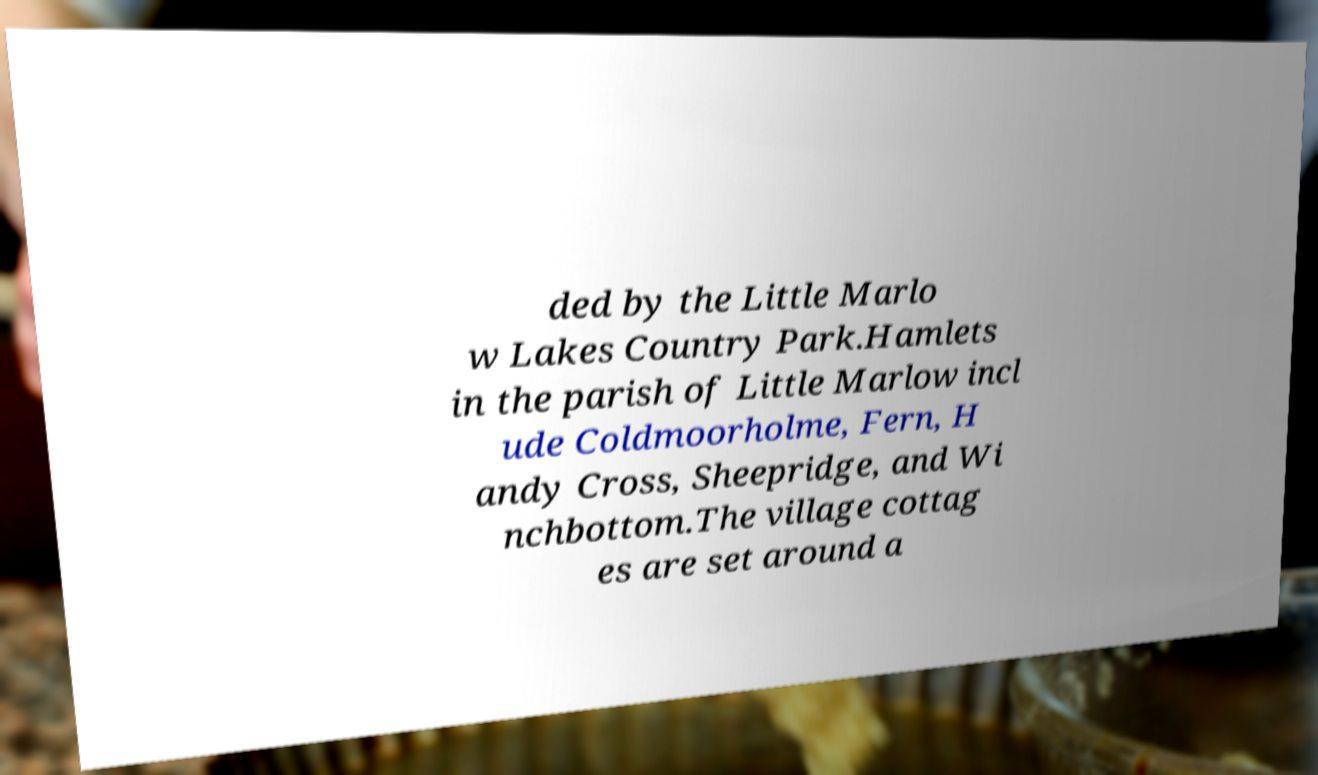Could you extract and type out the text from this image? ded by the Little Marlo w Lakes Country Park.Hamlets in the parish of Little Marlow incl ude Coldmoorholme, Fern, H andy Cross, Sheepridge, and Wi nchbottom.The village cottag es are set around a 